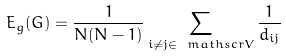Convert formula to latex. <formula><loc_0><loc_0><loc_500><loc_500>E _ { g } ( G ) = \frac { 1 } { N ( N - 1 ) } \sum _ { i \neq j \in \ m a t h s c r { V } } { \frac { 1 } { d _ { i j } } }</formula> 